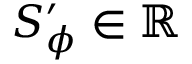Convert formula to latex. <formula><loc_0><loc_0><loc_500><loc_500>S _ { \phi } ^ { \prime } \in \mathbb { R }</formula> 